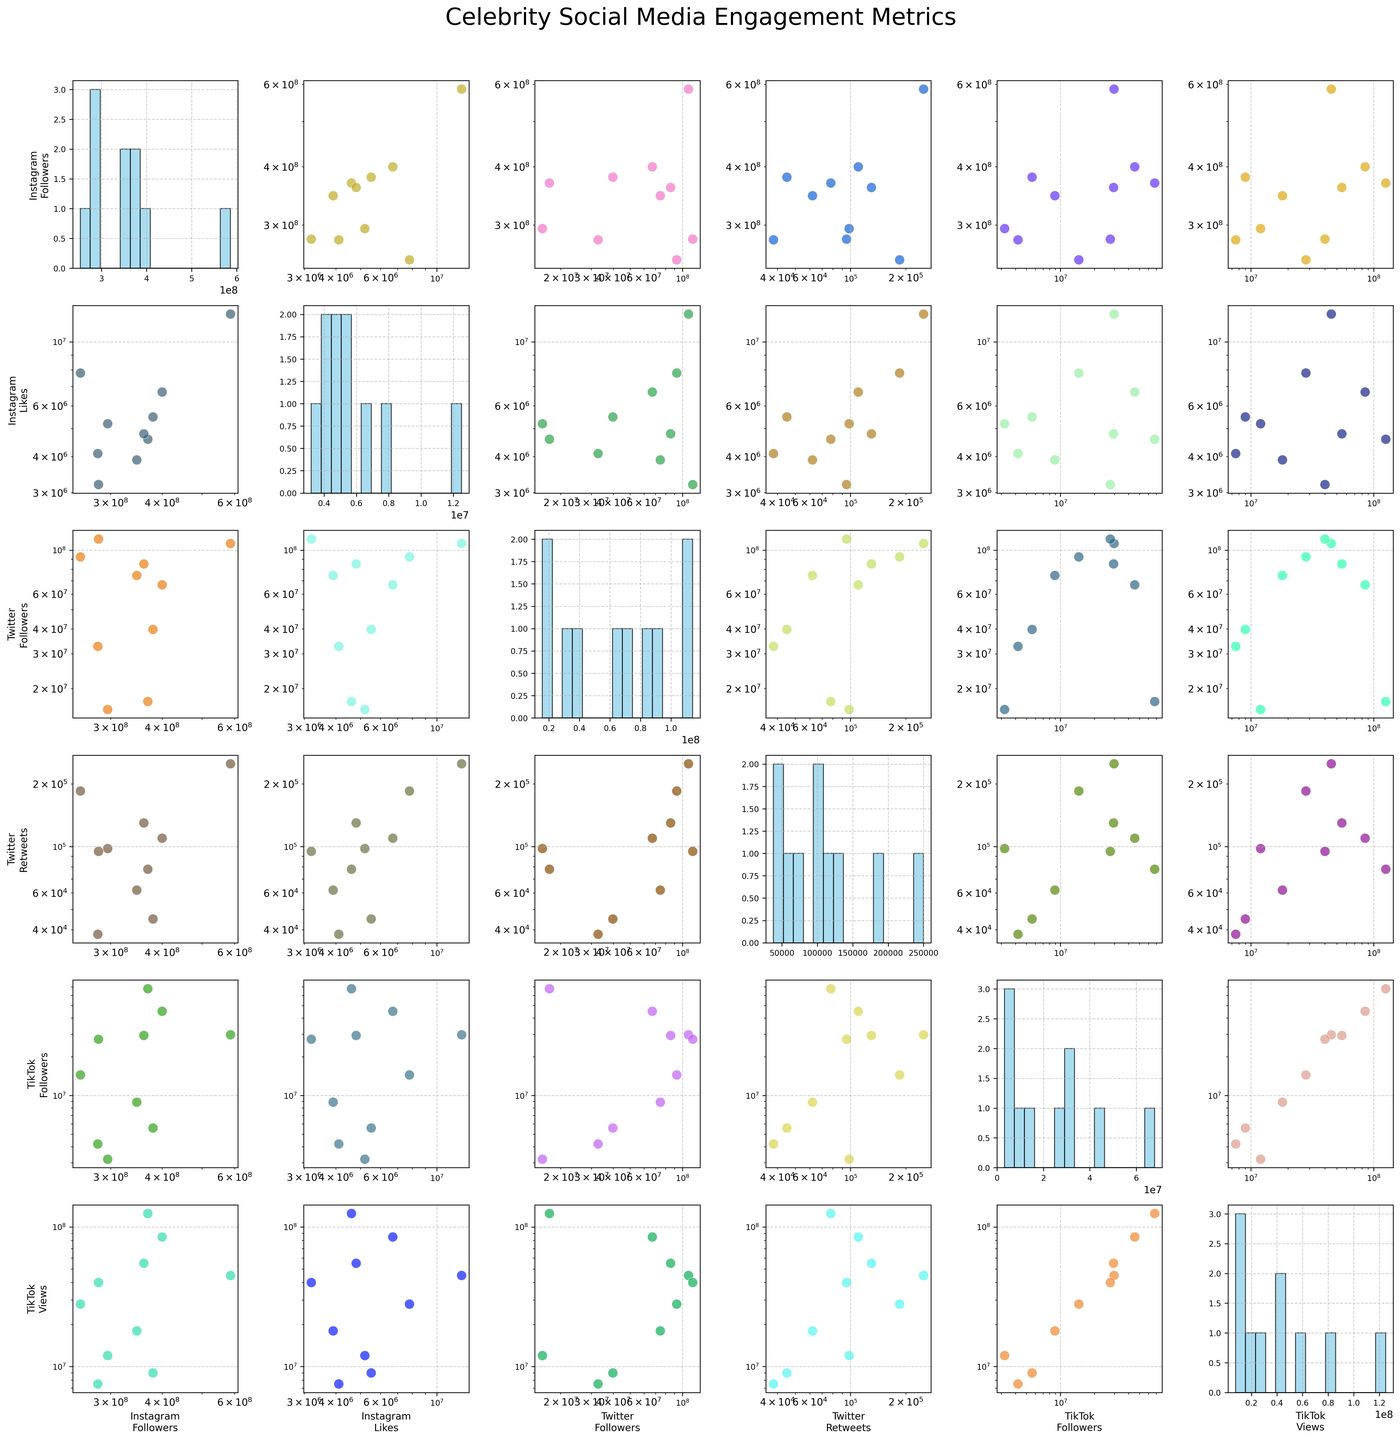Which social media platform shows the largest spread of follower counts? By looking at the histograms along the diagonal of the scatterplot matrix, we can compare spreads. The histogram for TikTok Followers shows the widest range of values compared to Instagram Followers and Twitter Followers.
Answer: TikTok Followers Which plot compares Twitter Followers and Instagram Followers? We look for the scatterplot where the x-axis is labeled "Twitter Followers" and the y-axis is labeled "Instagram Followers". This occurs in the second row, third column of the scatterplot.
Answer: 2nd row, 3rd column Do any outliers exist in the Instagram Likes data? Observing the histogram for Instagram Likes along the diagonal, we see that most celebrities have likes clustering within a certain range, but there are a few bars representing much higher values, indicating potential outliers.
Answer: Yes Which platform has the highest median engagement (likes/retweets/views)? We need to compare the median points for Instagram Likes, Twitter Retweets, and TikTok Views across the histograms. Evaluating visually, TikTok Views has the histogram centered around higher values compared to the other two.
Answer: TikTok Views Is there a correlation between Instagram Followers and TikTok Followers? To assess this, we look at the scatterplot intersecting Instagram Followers on the y-axis and TikTok Followers on the x-axis. We can see if the data points form any trend. The scatterplot shows a positive correlation, indicating that celebrities with more Instagram Followers often have more TikTok Followers.
Answer: Positive correlation What colors are used for the scatter data points? By examining various scatterplots, the colors appear to be randomly chosen but consistently vibrant, and visually distinct across the plots.
Answer: Random vibrant colors Between Instagram Followers and Twitter Followers, which has a more homogeneous distribution across celebrities? Checking histograms along the diagonal for both, Instagram Followers histogram shows a more even distribution across bins compared to Twitter Followers where values are more skewed.
Answer: Instagram Followers Which celebrity has the highest Instagram Likes? By looking at the highest bar in the Instagram Likes histogram or the highest y-value in scatterplots involving Instagram Likes, it corresponds to Taylor Swift.
Answer: Taylor Swift What's the average number of comments for celebrities on Twitter (assuming retweets represent comments)? Assuming Twitter Retweets represent comments, we can average the values from the histogram or scatter values. Sum of Twitter Retweets (98,000 + 185,000 + 250,000 + 62,000 + 78,000 + 110,000 + 45,000 + 130,000 + 95,000 + 38,000) equals 1,091,000. Dividing by 10 (number of celebrities) gives an average of 109,100.
Answer: 109,100 